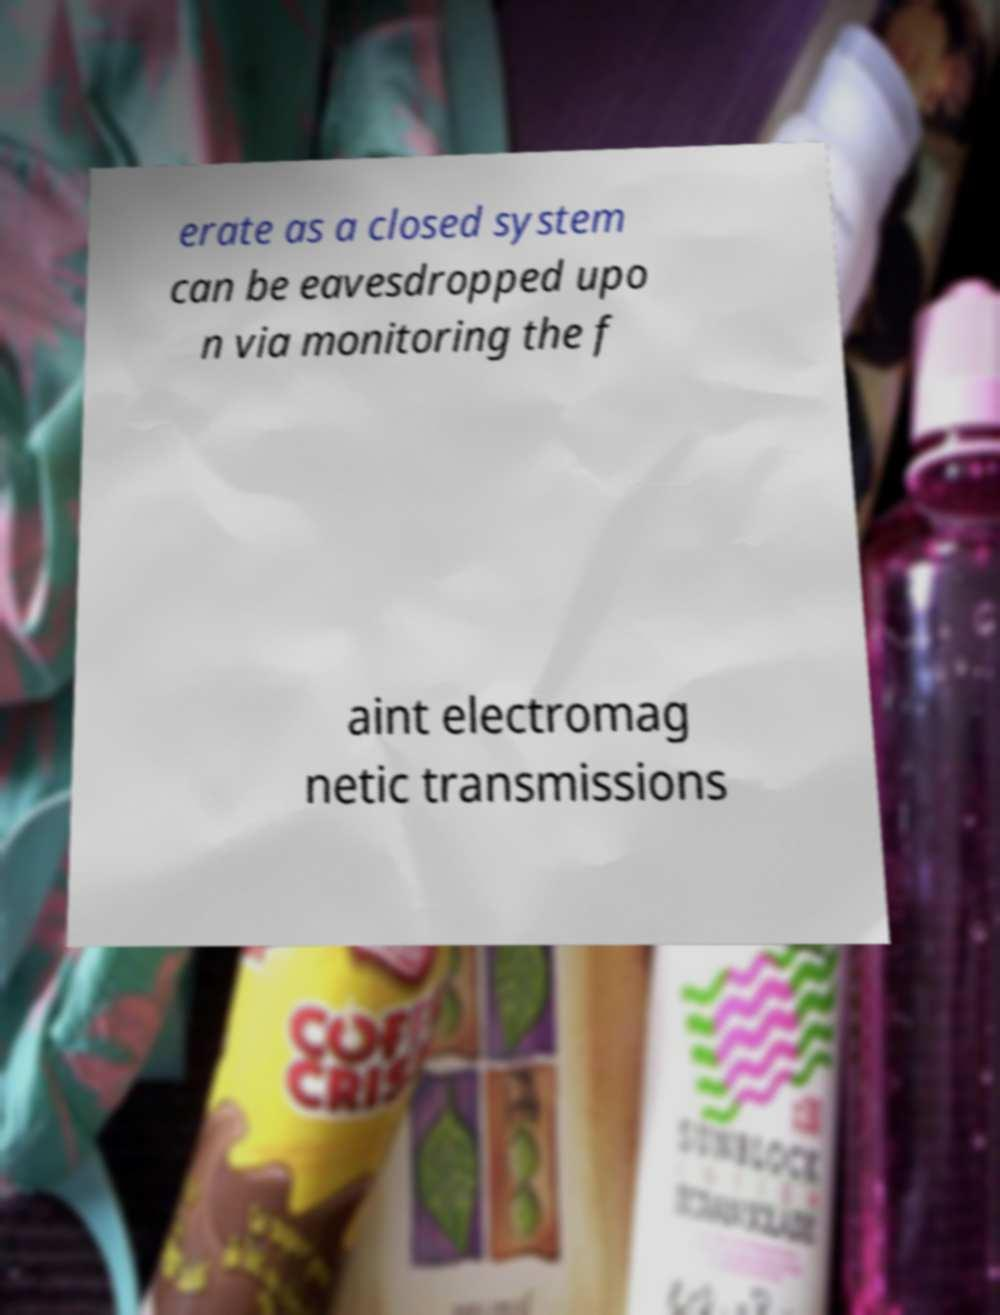Please read and relay the text visible in this image. What does it say? erate as a closed system can be eavesdropped upo n via monitoring the f aint electromag netic transmissions 